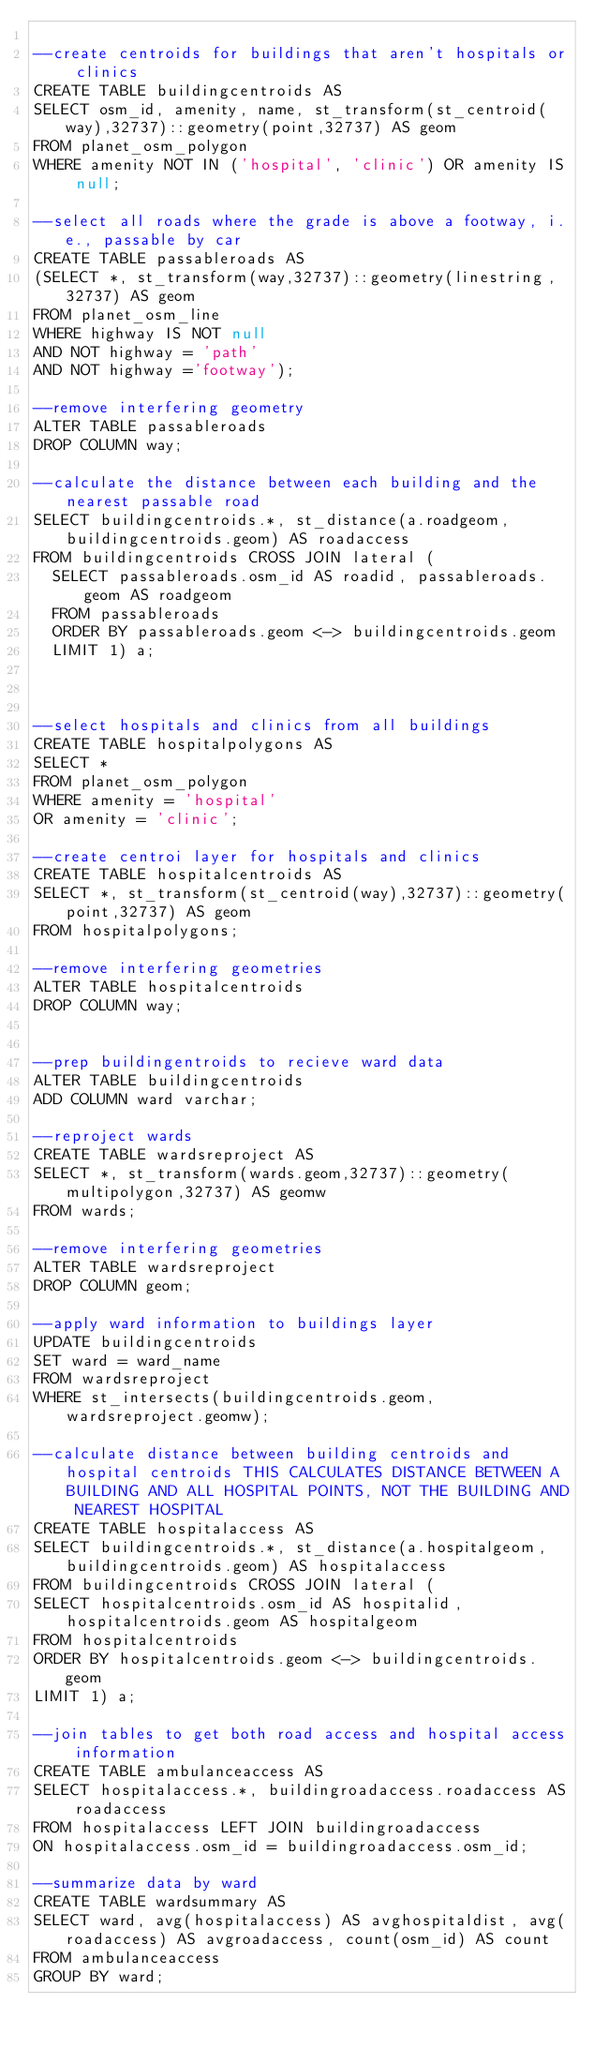Convert code to text. <code><loc_0><loc_0><loc_500><loc_500><_SQL_>
--create centroids for buildings that aren't hospitals or clinics
CREATE TABLE buildingcentroids AS
SELECT osm_id, amenity, name, st_transform(st_centroid(way),32737)::geometry(point,32737) AS geom
FROM planet_osm_polygon
WHERE amenity NOT IN ('hospital', 'clinic') OR amenity IS null;

--select all roads where the grade is above a footway, i.e., passable by car
CREATE TABLE passableroads AS
(SELECT *, st_transform(way,32737)::geometry(linestring, 32737) AS geom
FROM planet_osm_line
WHERE highway IS NOT null
AND NOT highway = 'path'
AND NOT highway ='footway');

--remove interfering geometry
ALTER TABLE passableroads
DROP COLUMN way;

--calculate the distance between each building and the nearest passable road
SELECT buildingcentroids.*, st_distance(a.roadgeom, buildingcentroids.geom) AS roadaccess
FROM buildingcentroids CROSS JOIN lateral (
	SELECT passableroads.osm_id AS roadid, passableroads.geom AS roadgeom
	FROM passableroads
	ORDER BY passableroads.geom <-> buildingcentroids.geom
	LIMIT 1) a;



--select hospitals and clinics from all buildings
CREATE TABLE hospitalpolygons AS
SELECT *
FROM planet_osm_polygon
WHERE amenity = 'hospital'
OR amenity = 'clinic';

--create centroi layer for hospitals and clinics
CREATE TABLE hospitalcentroids AS
SELECT *, st_transform(st_centroid(way),32737)::geometry(point,32737) AS geom
FROM hospitalpolygons;

--remove interfering geometries
ALTER TABLE hospitalcentroids
DROP COLUMN way;


--prep buildingentroids to recieve ward data
ALTER TABLE buildingcentroids
ADD COLUMN ward varchar;

--reproject wards
CREATE TABLE wardsreproject AS
SELECT *, st_transform(wards.geom,32737)::geometry(multipolygon,32737) AS geomw
FROM wards;

--remove interfering geometries
ALTER TABLE wardsreproject
DROP COLUMN geom;

--apply ward information to buildings layer
UPDATE buildingcentroids
SET ward = ward_name
FROM wardsreproject
WHERE st_intersects(buildingcentroids.geom, wardsreproject.geomw);

--calculate distance between building centroids and hospital centroids THIS CALCULATES DISTANCE BETWEEN A BUILDING AND ALL HOSPITAL POINTS, NOT THE BUILDING AND NEAREST HOSPITAL
CREATE TABLE hospitalaccess AS
SELECT buildingcentroids.*, st_distance(a.hospitalgeom, buildingcentroids.geom) AS hospitalaccess
FROM buildingcentroids CROSS JOIN lateral (
SELECT hospitalcentroids.osm_id AS hospitalid, hospitalcentroids.geom AS hospitalgeom
FROM hospitalcentroids
ORDER BY hospitalcentroids.geom <-> buildingcentroids.geom
LIMIT 1) a;

--join tables to get both road access and hospital access information
CREATE TABLE ambulanceaccess AS
SELECT hospitalaccess.*, buildingroadaccess.roadaccess AS roadaccess
FROM hospitalaccess LEFT JOIN buildingroadaccess
ON hospitalaccess.osm_id = buildingroadaccess.osm_id;

--summarize data by ward
CREATE TABLE wardsummary AS
SELECT ward, avg(hospitalaccess) AS avghospitaldist, avg(roadaccess) AS avgroadaccess, count(osm_id) AS count
FROM ambulanceaccess
GROUP BY ward;
</code> 